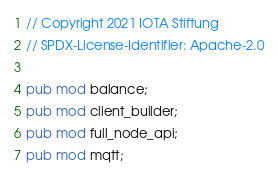<code> <loc_0><loc_0><loc_500><loc_500><_Rust_>// Copyright 2021 IOTA Stiftung
// SPDX-License-Identifier: Apache-2.0

pub mod balance;
pub mod client_builder;
pub mod full_node_api;
pub mod mqtt;
</code> 